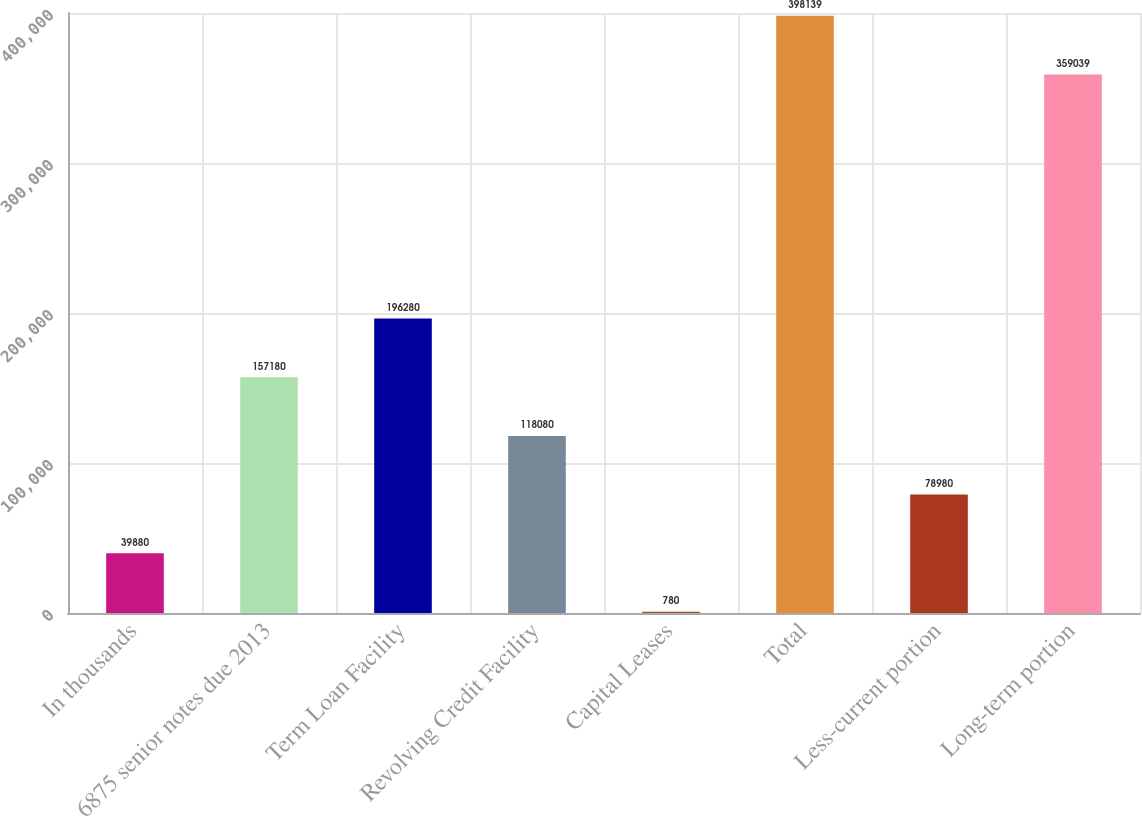Convert chart to OTSL. <chart><loc_0><loc_0><loc_500><loc_500><bar_chart><fcel>In thousands<fcel>6875 senior notes due 2013<fcel>Term Loan Facility<fcel>Revolving Credit Facility<fcel>Capital Leases<fcel>Total<fcel>Less-current portion<fcel>Long-term portion<nl><fcel>39880<fcel>157180<fcel>196280<fcel>118080<fcel>780<fcel>398139<fcel>78980<fcel>359039<nl></chart> 